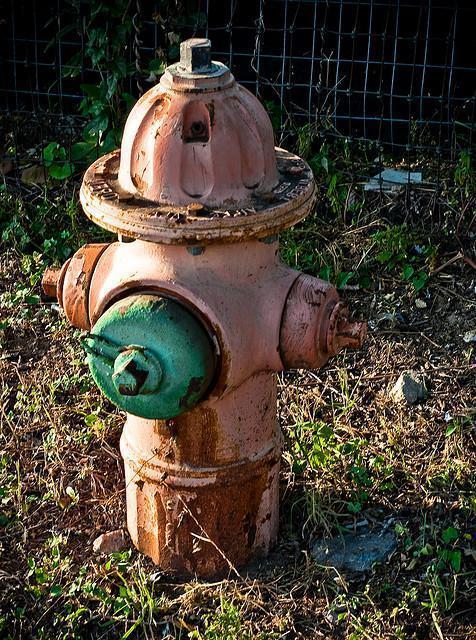How many people can you see on the television screen?
Give a very brief answer. 0. 